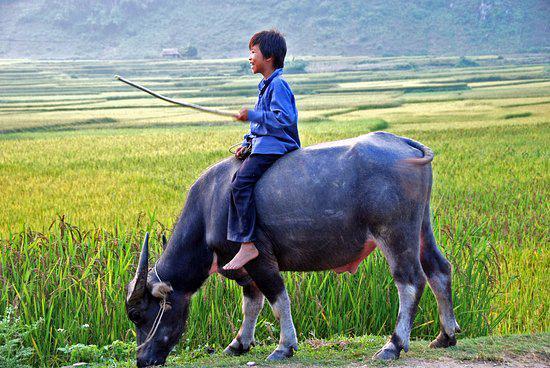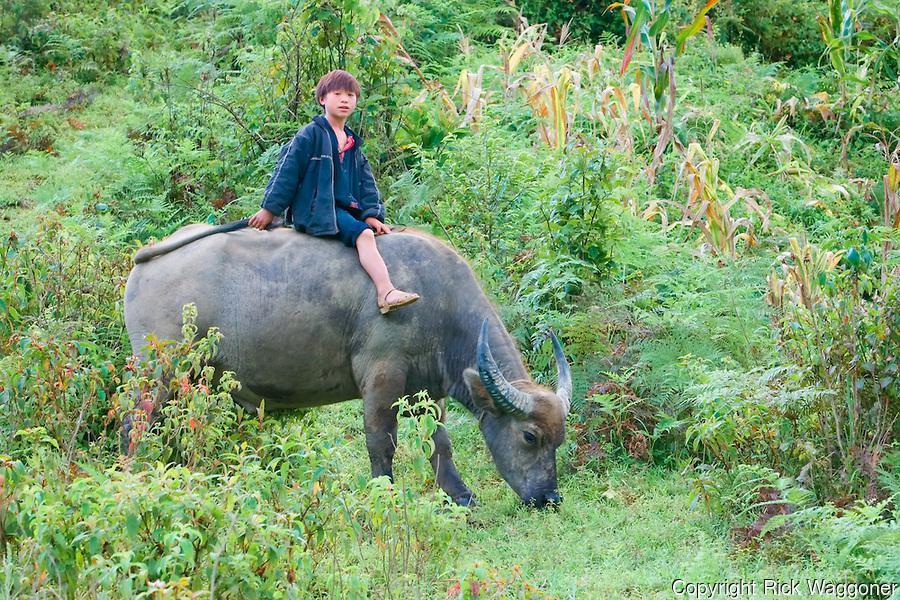The first image is the image on the left, the second image is the image on the right. Given the left and right images, does the statement "The right image shows a child straddling the back of a right-facing water buffalo, and the left image shows a boy holding a stick extended forward while on the back of a water buffalo." hold true? Answer yes or no. Yes. The first image is the image on the left, the second image is the image on the right. Evaluate the accuracy of this statement regarding the images: "In at least one image there are three males with short black hair and at least one male is riding an ox.". Is it true? Answer yes or no. No. 